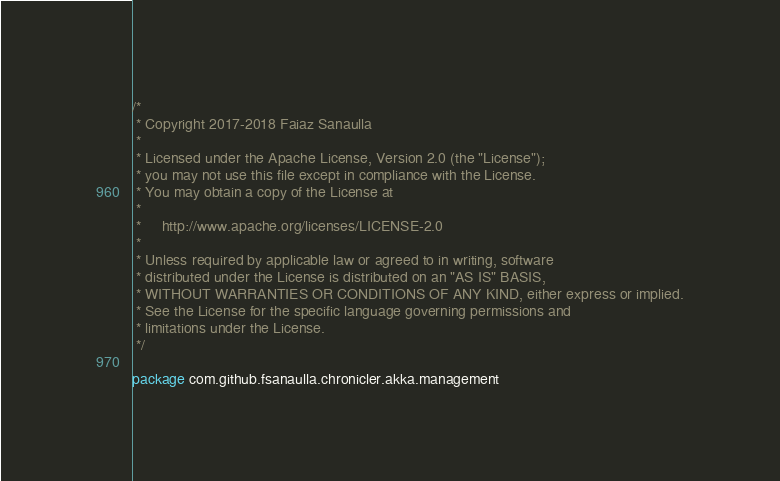Convert code to text. <code><loc_0><loc_0><loc_500><loc_500><_Scala_>/*
 * Copyright 2017-2018 Faiaz Sanaulla
 *
 * Licensed under the Apache License, Version 2.0 (the "License");
 * you may not use this file except in compliance with the License.
 * You may obtain a copy of the License at
 *
 *     http://www.apache.org/licenses/LICENSE-2.0
 *
 * Unless required by applicable law or agreed to in writing, software
 * distributed under the License is distributed on an "AS IS" BASIS,
 * WITHOUT WARRANTIES OR CONDITIONS OF ANY KIND, either express or implied.
 * See the License for the specific language governing permissions and
 * limitations under the License.
 */

package com.github.fsanaulla.chronicler.akka.management
</code> 